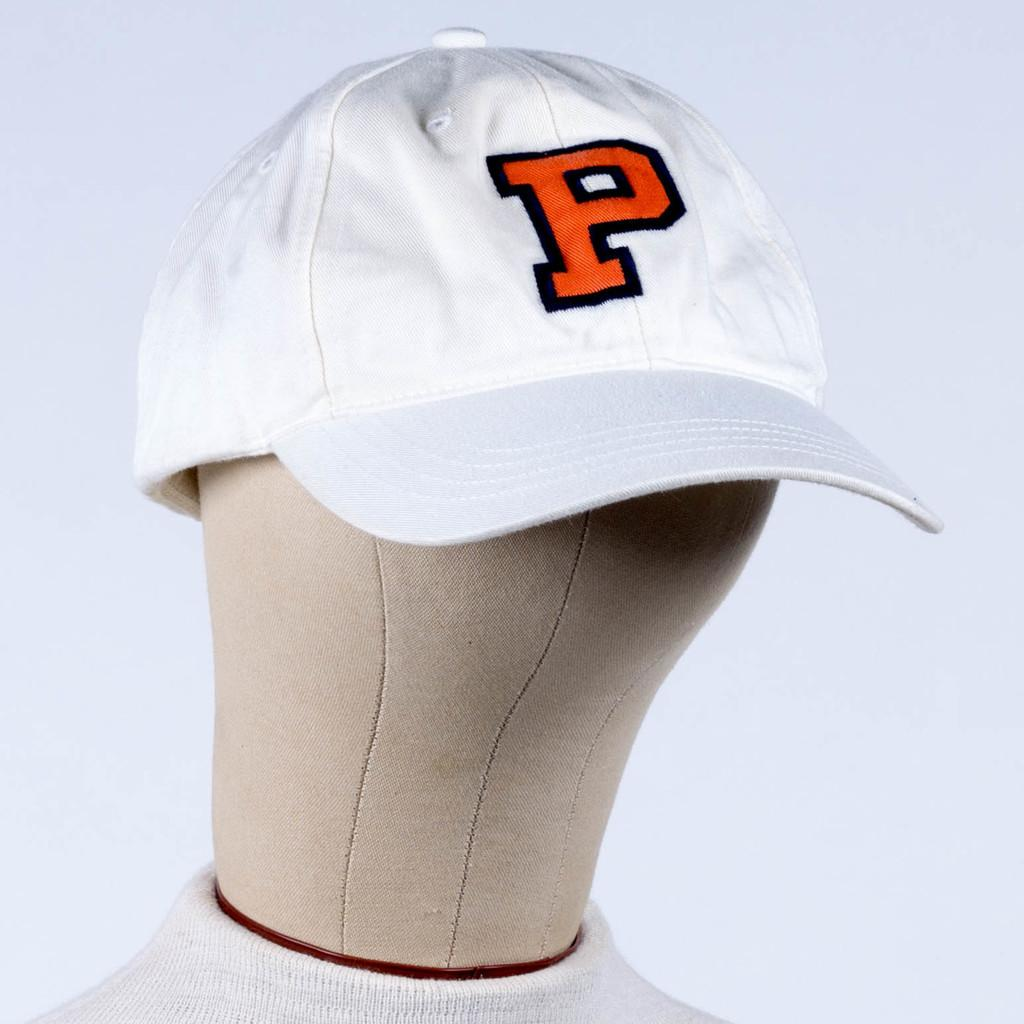What object can be seen in the image? There is a toy in the image. Can you describe the toy's appearance? The toy is wearing a cap. What type of prison is depicted in the image? There is no prison present in the image; it features a toy wearing a cap. Can you describe the pet that is visible in the image? There is no pet present in the image; it features a toy wearing a cap. 